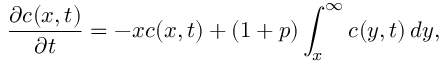<formula> <loc_0><loc_0><loc_500><loc_500>{ \frac { \partial c ( x , t ) } { \partial t } } = - x c ( x , t ) + ( 1 + p ) \int _ { x } ^ { \infty } c ( y , t ) \, d y ,</formula> 